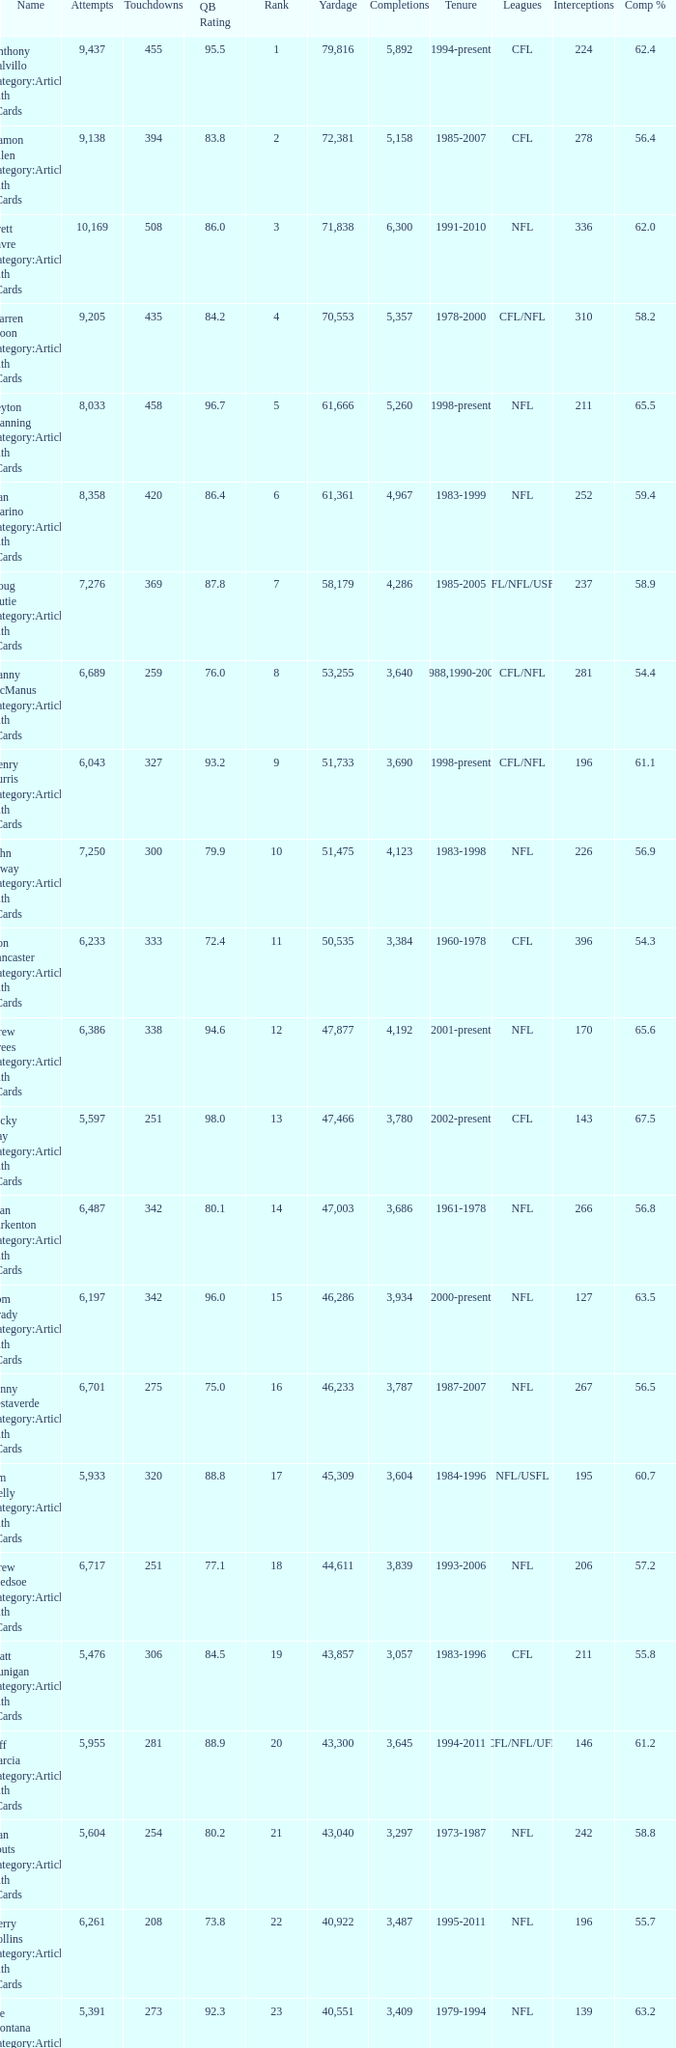What is the rank when there are more than 4,123 completion and the comp percentage is more than 65.6? None. 